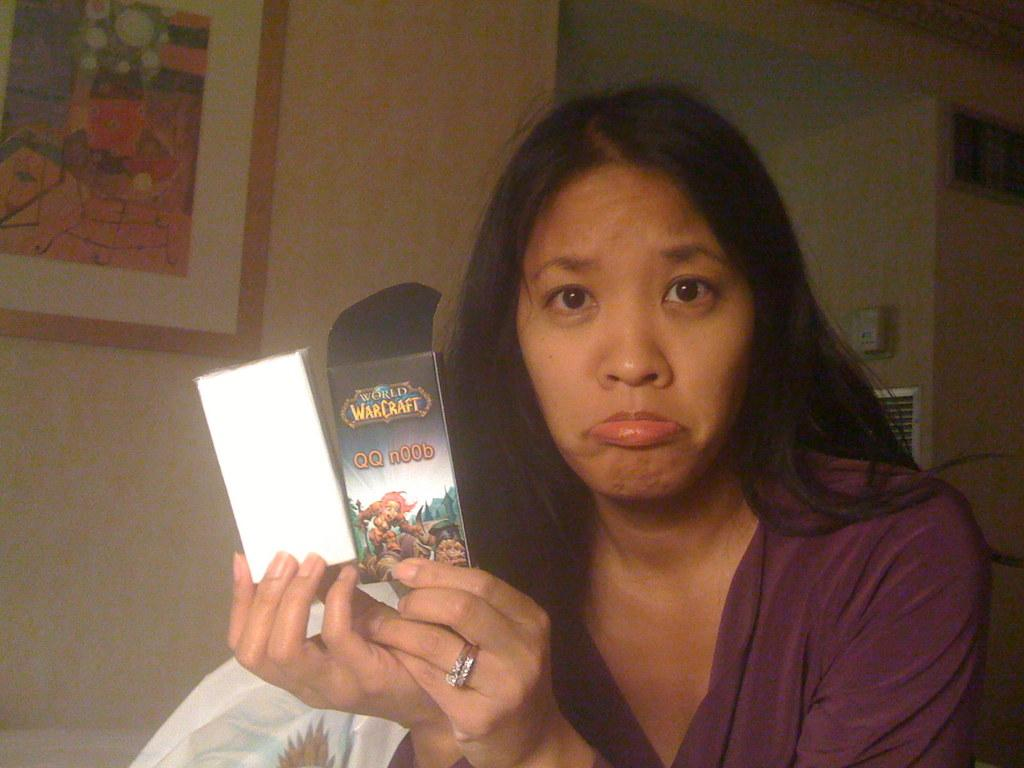Who is the main subject in the image? There is a lady in the image. What is the lady wearing? The lady is wearing a violet dress. What is the lady holding in her hand? The lady is holding something in her hand, but the specific object is not mentioned in the facts. What can be seen on the wall in the background? There is a wall with a frame on it in the background. What type of apparel is the bee wearing in the image? There is no bee present in the image, so it is not possible to determine what type of apparel a bee might be wearing. 